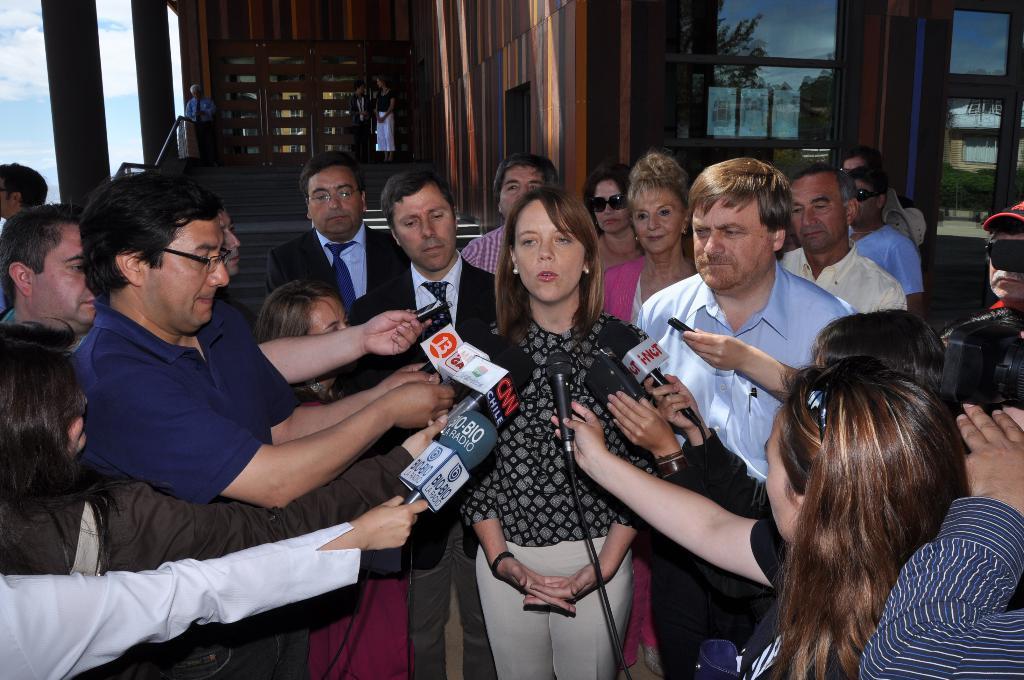Can you describe this image briefly? In this image we can see people holding mics. There is a lady standing. In the background of the image there is a building. There are staircase. There is a staircase railing. To the left side of the image there is sky and clouds. 